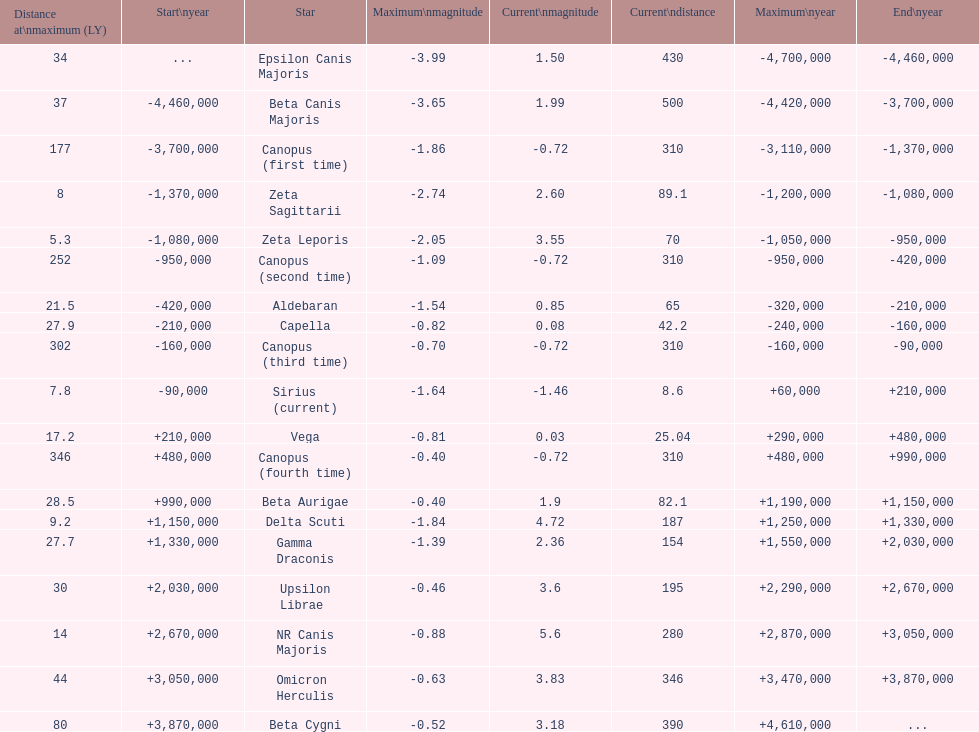How many stars do not have a current magnitude greater than zero? 5. 